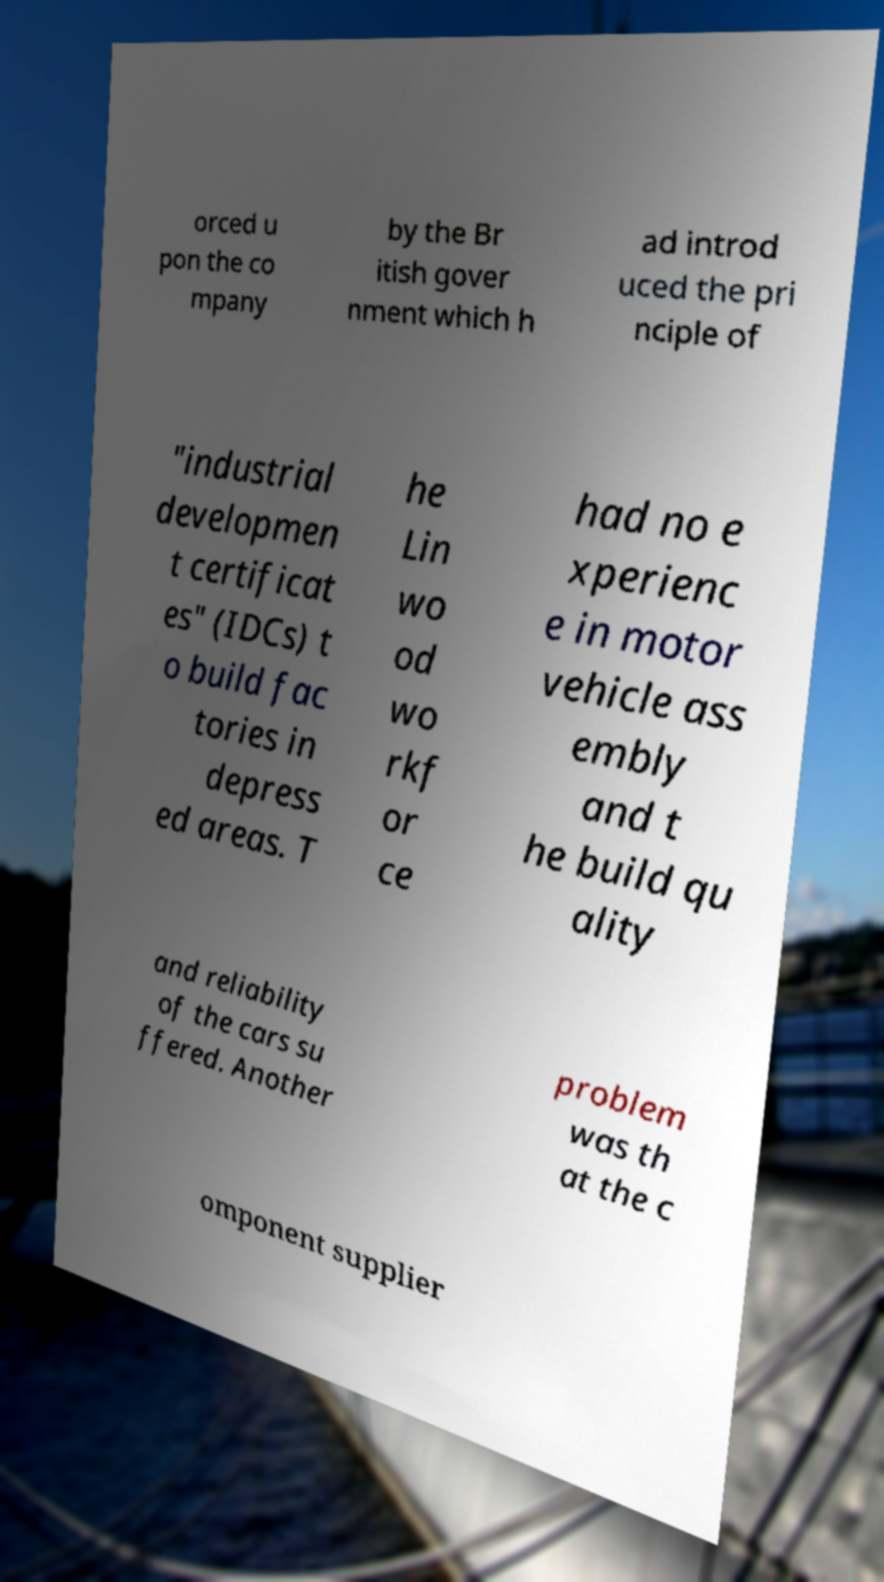Please identify and transcribe the text found in this image. orced u pon the co mpany by the Br itish gover nment which h ad introd uced the pri nciple of "industrial developmen t certificat es" (IDCs) t o build fac tories in depress ed areas. T he Lin wo od wo rkf or ce had no e xperienc e in motor vehicle ass embly and t he build qu ality and reliability of the cars su ffered. Another problem was th at the c omponent supplier 